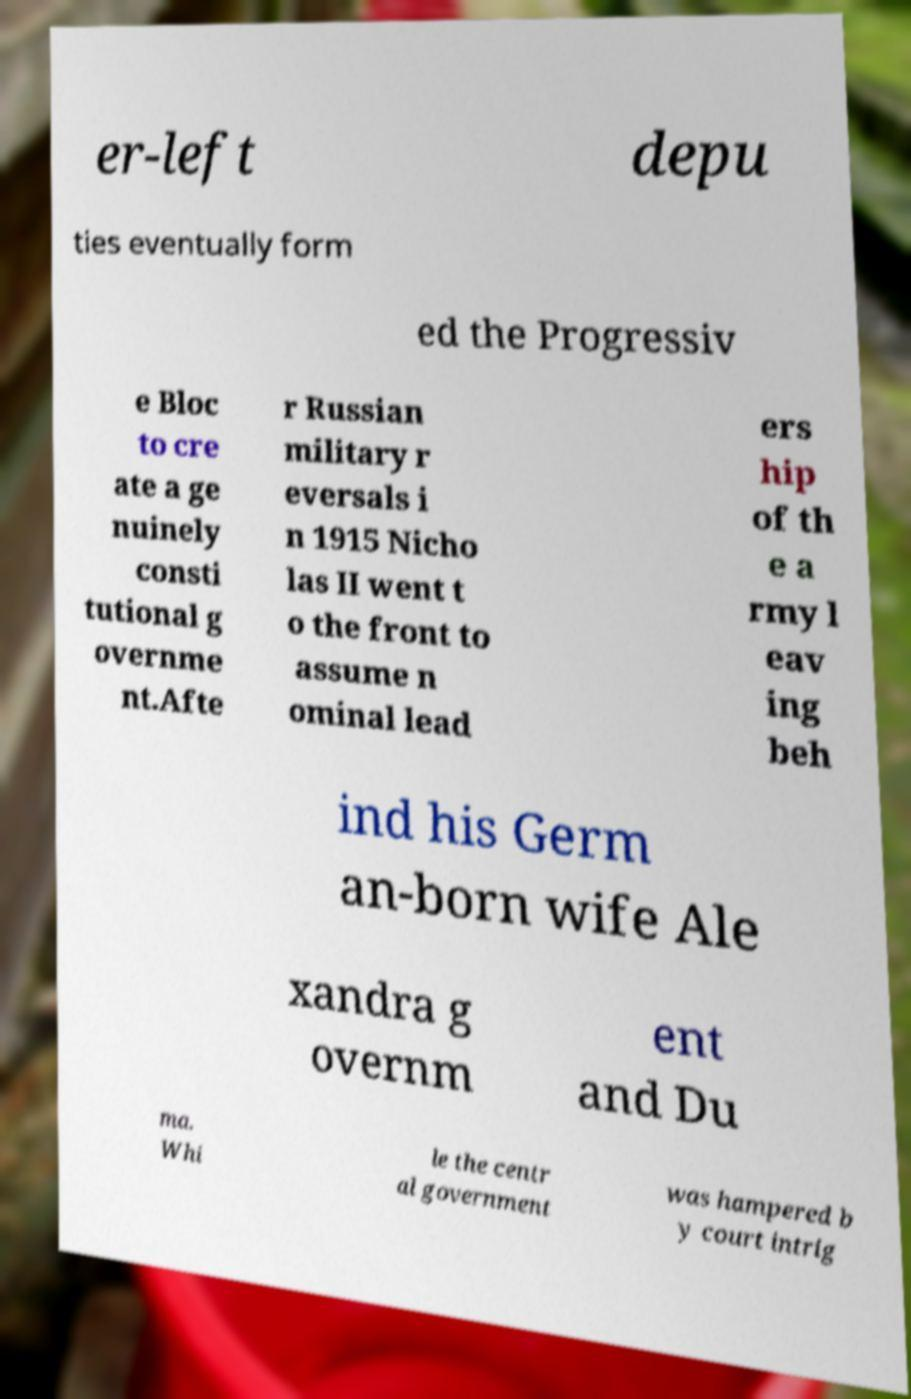There's text embedded in this image that I need extracted. Can you transcribe it verbatim? er-left depu ties eventually form ed the Progressiv e Bloc to cre ate a ge nuinely consti tutional g overnme nt.Afte r Russian military r eversals i n 1915 Nicho las II went t o the front to assume n ominal lead ers hip of th e a rmy l eav ing beh ind his Germ an-born wife Ale xandra g overnm ent and Du ma. Whi le the centr al government was hampered b y court intrig 